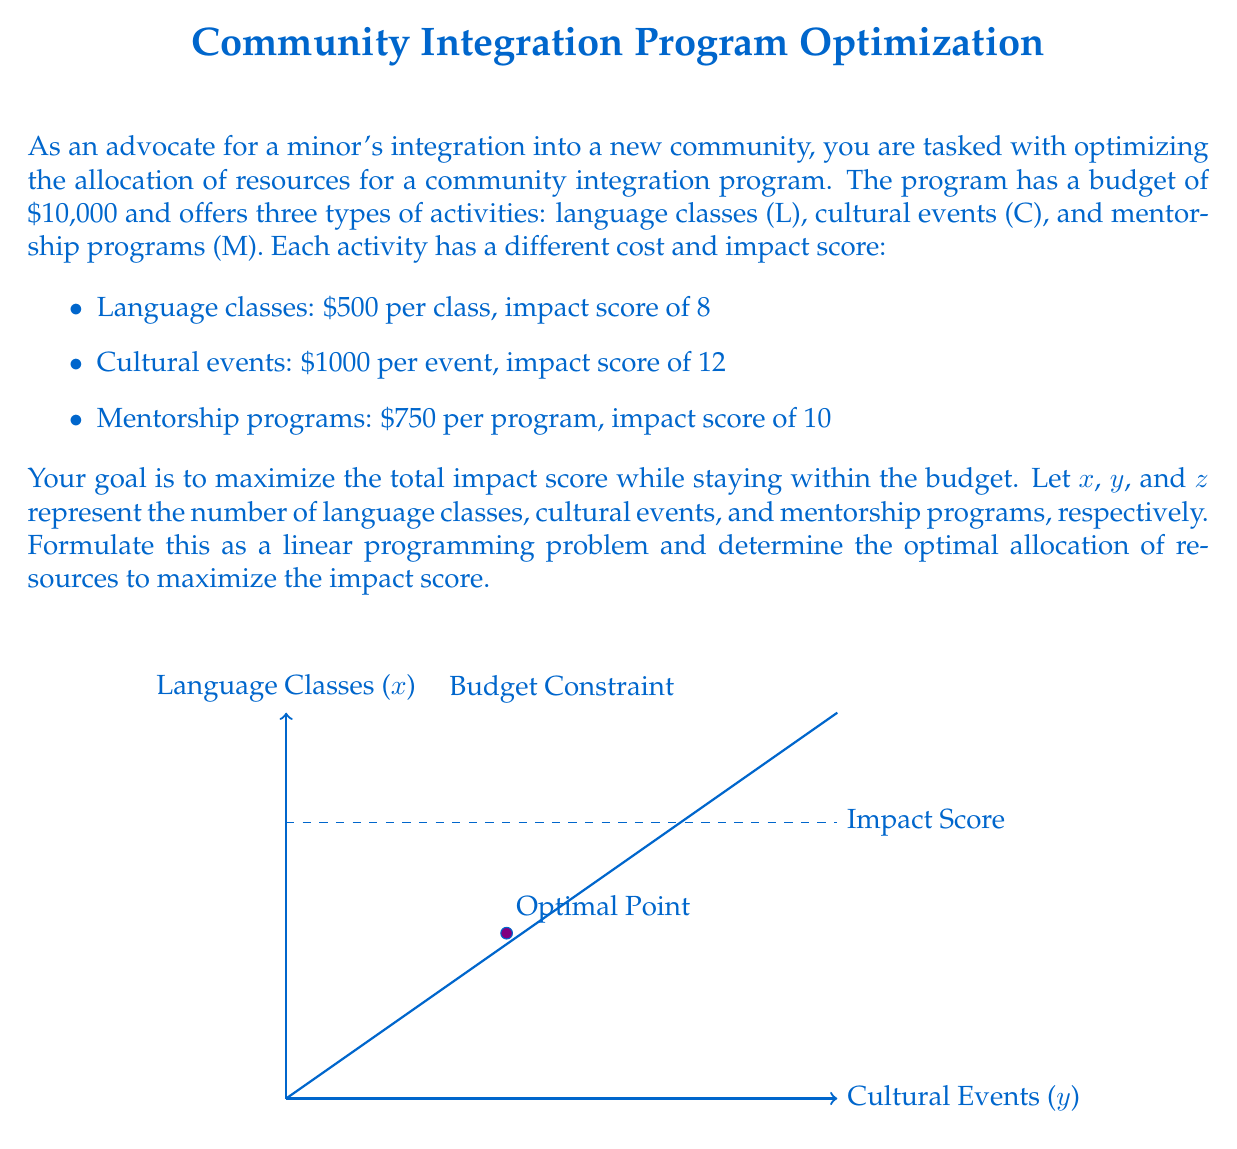Provide a solution to this math problem. Let's approach this step-by-step:

1) First, we need to formulate the objective function. We want to maximize the total impact score:

   Maximize: $8x + 12y + 10z$

2) Now, let's define the constraints:

   Budget constraint: $500x + 1000y + 750z \leq 10000$
   Non-negativity: $x \geq 0$, $y \geq 0$, $z \geq 0$
   Integer constraint: $x$, $y$, and $z$ must be integers

3) This is an integer linear programming problem. To solve it, we can use the simplex method and then round down to the nearest integer solution.

4) Using a linear programming solver, we get the following solution:
   $x = 8$, $y = 4$, $z = 0$

5) Let's verify:
   Cost: $500(8) + 1000(4) + 750(0) = 8000$
   Impact score: $8(8) + 12(4) + 10(0) = 112$

6) We can't increase any variable without exceeding the budget, so this is optimal.

Therefore, the optimal allocation is 8 language classes and 4 cultural events, with no mentorship programs. This gives a maximum impact score of 112 while using $8,000 of the $10,000 budget.
Answer: 8 language classes, 4 cultural events, 0 mentorship programs 